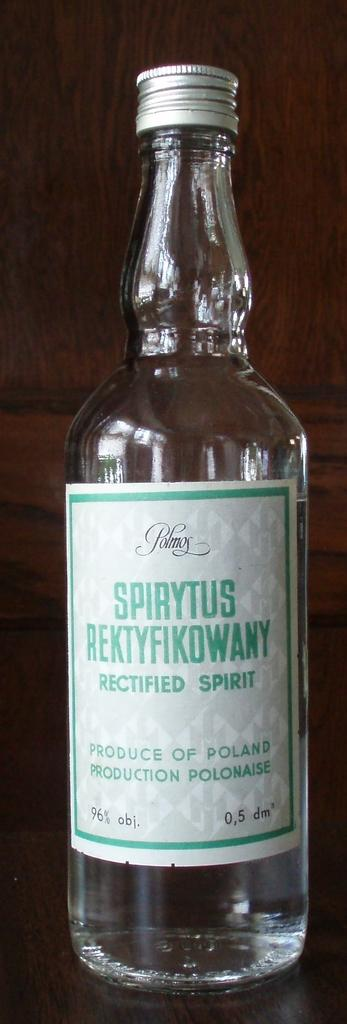Provide a one-sentence caption for the provided image. A bottle of Spirytus Rektyfikowany rectified spirit sits on a counter. 